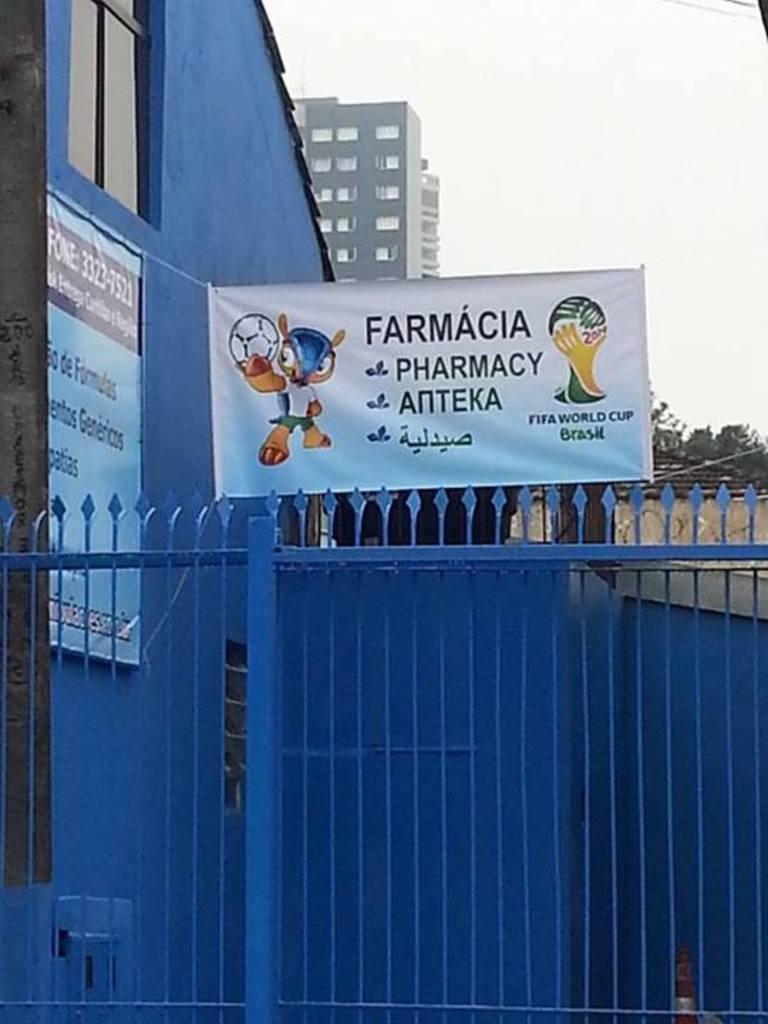<image>
Provide a brief description of the given image. A blue fence has a sign above it that says Farmacia Pharmacy. 